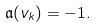Convert formula to latex. <formula><loc_0><loc_0><loc_500><loc_500>\mathfrak { a } ( v _ { k } ) = - 1 .</formula> 